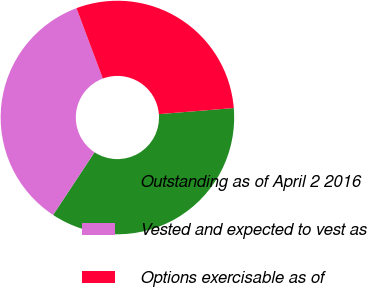<chart> <loc_0><loc_0><loc_500><loc_500><pie_chart><fcel>Outstanding as of April 2 2016<fcel>Vested and expected to vest as<fcel>Options exercisable as of<nl><fcel>35.58%<fcel>35.01%<fcel>29.41%<nl></chart> 